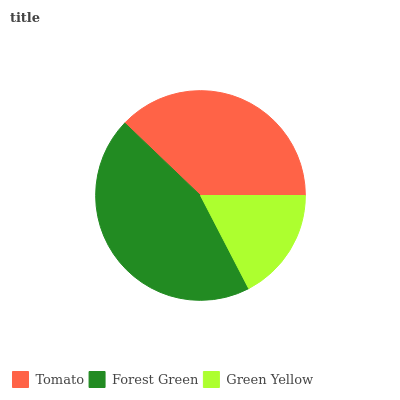Is Green Yellow the minimum?
Answer yes or no. Yes. Is Forest Green the maximum?
Answer yes or no. Yes. Is Forest Green the minimum?
Answer yes or no. No. Is Green Yellow the maximum?
Answer yes or no. No. Is Forest Green greater than Green Yellow?
Answer yes or no. Yes. Is Green Yellow less than Forest Green?
Answer yes or no. Yes. Is Green Yellow greater than Forest Green?
Answer yes or no. No. Is Forest Green less than Green Yellow?
Answer yes or no. No. Is Tomato the high median?
Answer yes or no. Yes. Is Tomato the low median?
Answer yes or no. Yes. Is Green Yellow the high median?
Answer yes or no. No. Is Green Yellow the low median?
Answer yes or no. No. 